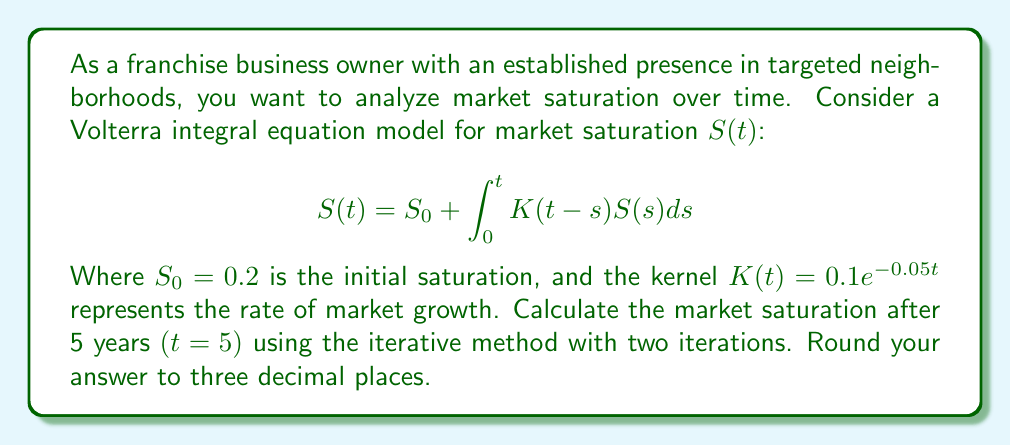Could you help me with this problem? To solve this Volterra integral equation, we'll use the iterative method:

1) Start with the initial approximation $S_0(t) = 0.2$ (the constant function).

2) For the first iteration:
   $$S_1(t) = 0.2 + \int_0^t 0.1e^{-0.05(t-s)} \cdot 0.2 ds$$
   $$= 0.2 + 0.02 \int_0^t e^{-0.05(t-s)} ds$$
   $$= 0.2 + 0.02 \cdot \frac{1}{0.05}(1 - e^{-0.05t})$$
   $$= 0.2 + 0.4(1 - e^{-0.05t})$$

3) For the second iteration:
   $$S_2(t) = 0.2 + \int_0^t 0.1e^{-0.05(t-s)} \cdot [0.2 + 0.4(1 - e^{-0.05s})] ds$$
   $$= 0.2 + 0.02 \int_0^t e^{-0.05(t-s)} ds + 0.04 \int_0^t e^{-0.05(t-s)}(1 - e^{-0.05s}) ds$$
   $$= 0.2 + 0.4(1 - e^{-0.05t}) + 0.04 [\frac{1}{0.05}(1 - e^{-0.05t}) - \frac{1}{0.1}(1 - e^{-0.1t})]$$
   $$= 0.2 + 0.4(1 - e^{-0.05t}) + 0.8(1 - e^{-0.05t}) - 0.4(1 - e^{-0.1t})$$
   $$= 0.2 + 1.2(1 - e^{-0.05t}) - 0.4(1 - e^{-0.1t})$$

4) Evaluate $S_2(t)$ at $t = 5$:
   $$S_2(5) = 0.2 + 1.2(1 - e^{-0.25}) - 0.4(1 - e^{-0.5})$$
   $$\approx 0.2 + 1.2 \cdot 0.2212 - 0.4 \cdot 0.3935$$
   $$\approx 0.2 + 0.2654 - 0.1574$$
   $$\approx 0.3080$$

5) Rounding to three decimal places: 0.308
Answer: 0.308 